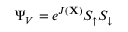<formula> <loc_0><loc_0><loc_500><loc_500>\Psi _ { V } = e ^ { J ( X ) } S _ { \uparrow } S _ { \downarrow }</formula> 